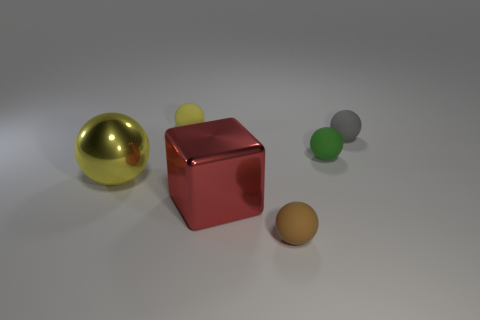Subtract all tiny yellow spheres. How many spheres are left? 4 Subtract all blue spheres. Subtract all cyan cylinders. How many spheres are left? 5 Add 4 small brown things. How many objects exist? 10 Subtract all cubes. How many objects are left? 5 Add 4 small red balls. How many small red balls exist? 4 Subtract 0 cyan cubes. How many objects are left? 6 Subtract all tiny brown spheres. Subtract all red metallic blocks. How many objects are left? 4 Add 3 small green rubber things. How many small green rubber things are left? 4 